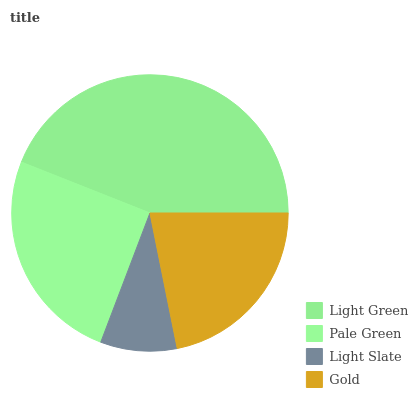Is Light Slate the minimum?
Answer yes or no. Yes. Is Light Green the maximum?
Answer yes or no. Yes. Is Pale Green the minimum?
Answer yes or no. No. Is Pale Green the maximum?
Answer yes or no. No. Is Light Green greater than Pale Green?
Answer yes or no. Yes. Is Pale Green less than Light Green?
Answer yes or no. Yes. Is Pale Green greater than Light Green?
Answer yes or no. No. Is Light Green less than Pale Green?
Answer yes or no. No. Is Pale Green the high median?
Answer yes or no. Yes. Is Gold the low median?
Answer yes or no. Yes. Is Light Green the high median?
Answer yes or no. No. Is Light Slate the low median?
Answer yes or no. No. 